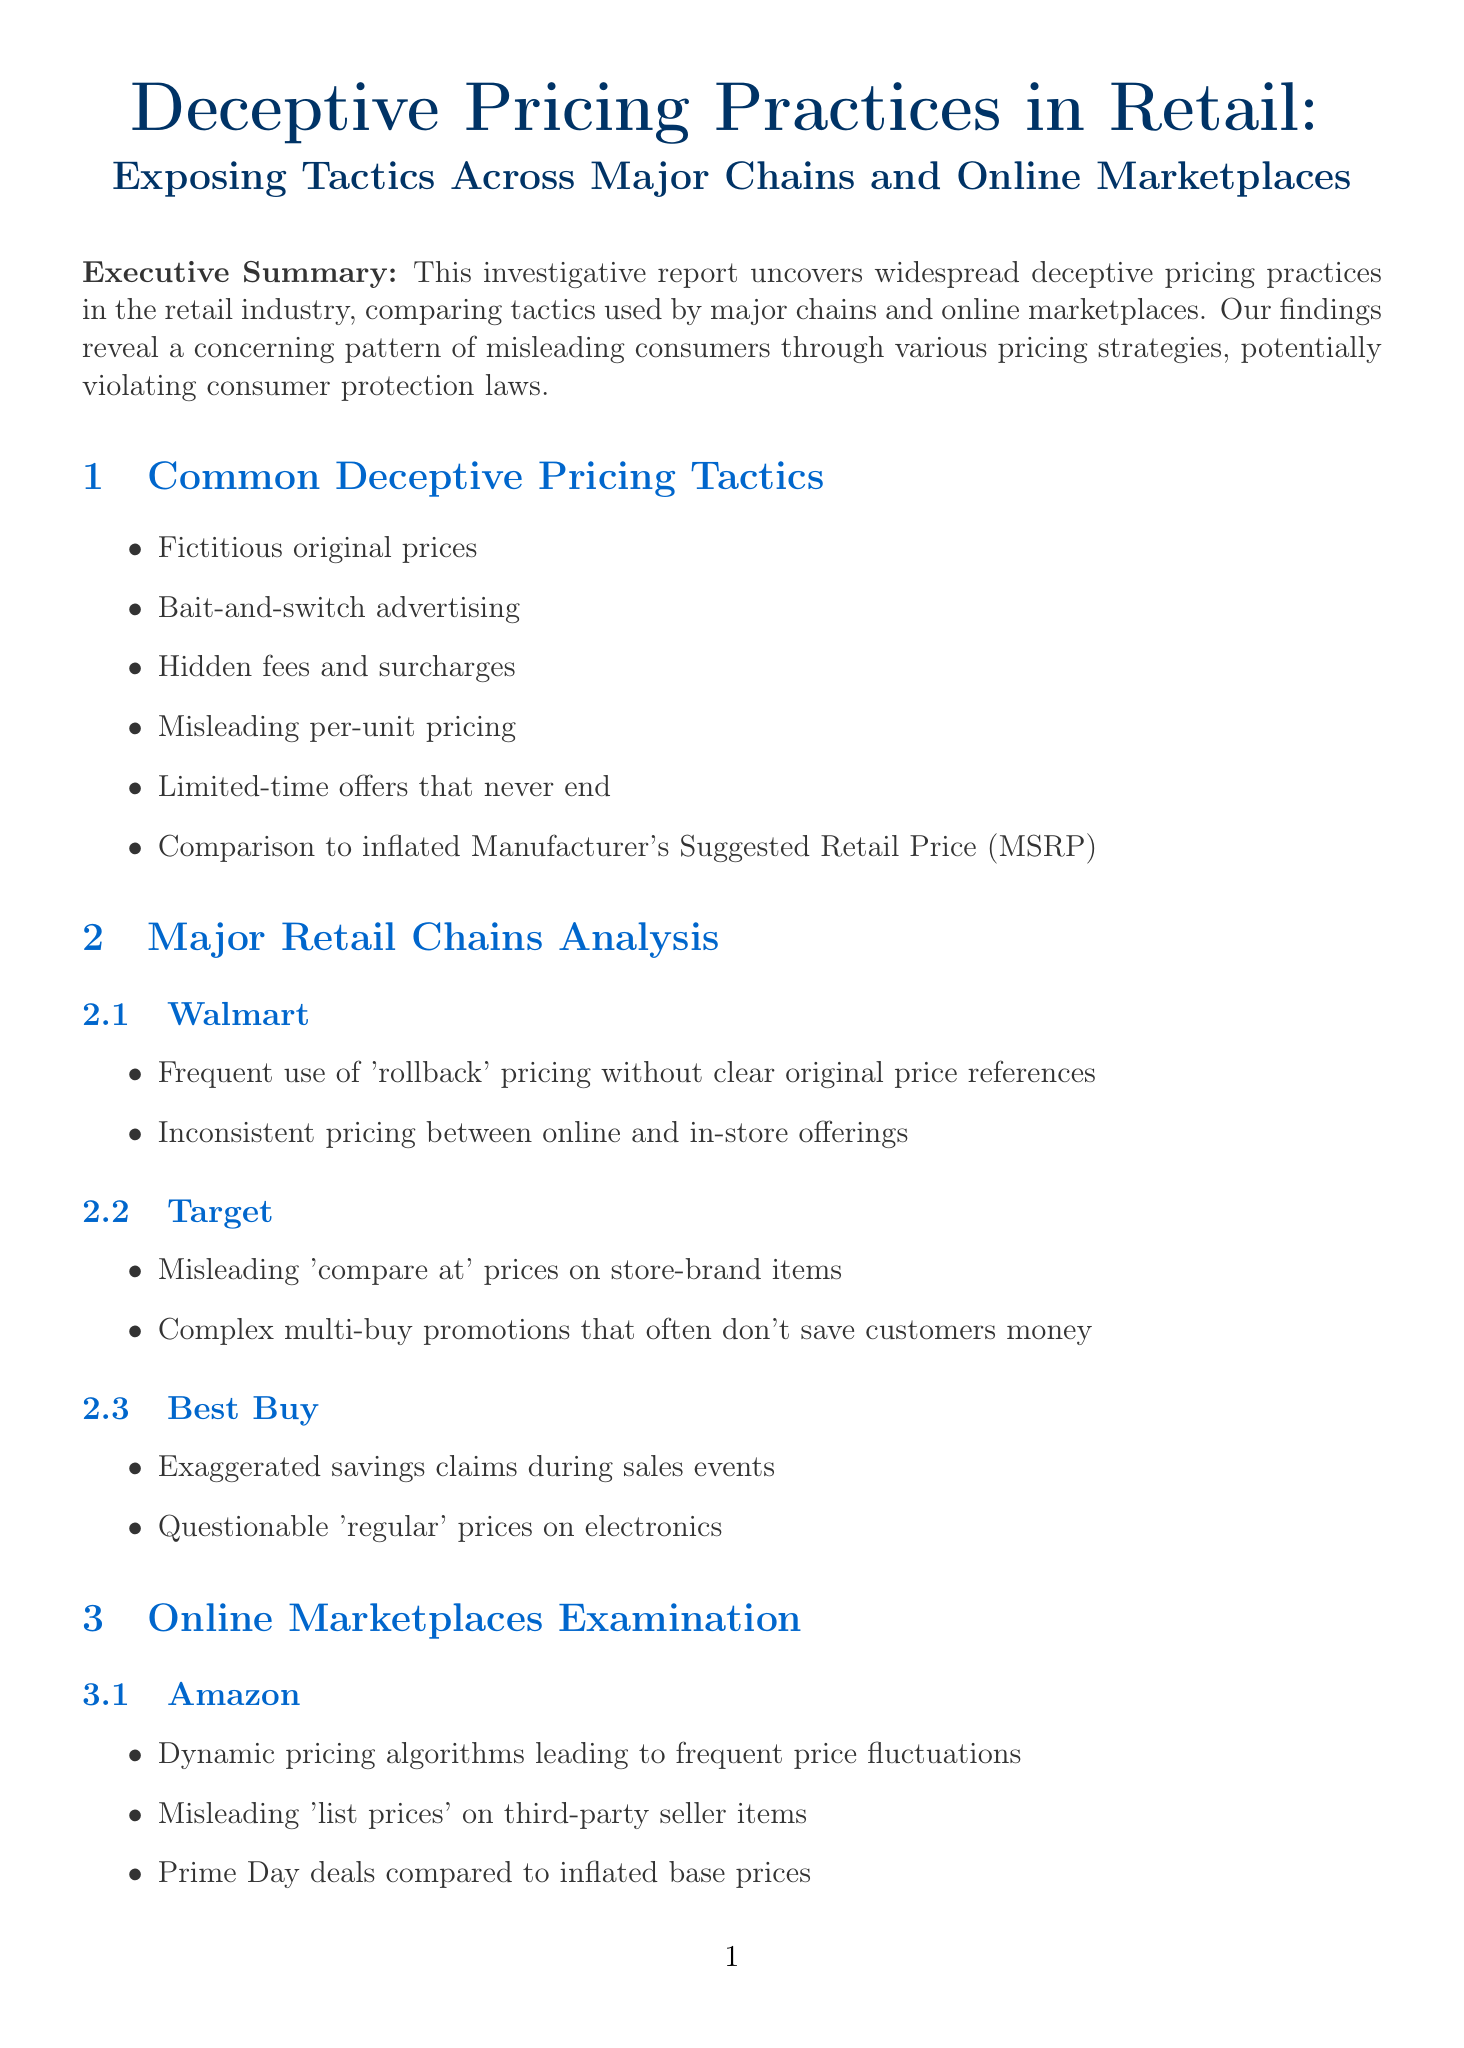What is the report title? The title of the report is the main heading provided at the beginning, outlining the subject of the document.
Answer: Deceptive Pricing Practices in Retail: Exposing Tactics Across Major Chains and Online Marketplaces How many major retail chains are analyzed in the report? The document lists the chains discussed in the "Major Retail Chains Analysis" section.
Answer: Three Which online marketplace is mentioned first in the examination? The order of online marketplaces is presented in the "Online Marketplaces Examination" section, starting with the first one listed.
Answer: Amazon What is one of the common deceptive pricing tactics identified? The report lists various tactics under the "Common Deceptive Pricing Tactics" section as examples of deceptive practices.
Answer: Fictitious original prices Who is Dr. Emily Chen? The document includes expert quotes, specifying their credentials and area of expertise.
Answer: Professor of Consumer Psychology, Stanford University What is one recommendation for consumers? The report offers several recommendations for consumers to avoid deceptive pricing, listed under the "Recommendations for Consumers" section.
Answer: Use price tracking tools like CamelCamelCamel for Amazon What did the investigation reveal about the prevalence of deceptive practices? The conclusion summarizes the findings regarding the existence of deceptive practices in the industry.
Answer: Pervasive Which state had a legal action against Overstock.com? The report states examples of state-level investigations and provides a specific case related to the company mentioned.
Answer: California 